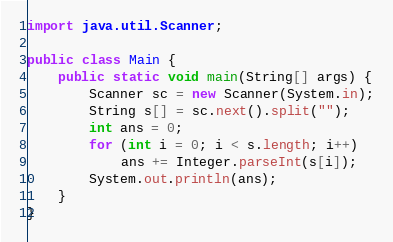<code> <loc_0><loc_0><loc_500><loc_500><_Java_>import java.util.Scanner;

public class Main {
	public static void main(String[] args) {
		Scanner sc = new Scanner(System.in);
		String s[] = sc.next().split("");
		int ans = 0;
		for (int i = 0; i < s.length; i++)
			ans += Integer.parseInt(s[i]);
		System.out.println(ans);
	}
}</code> 